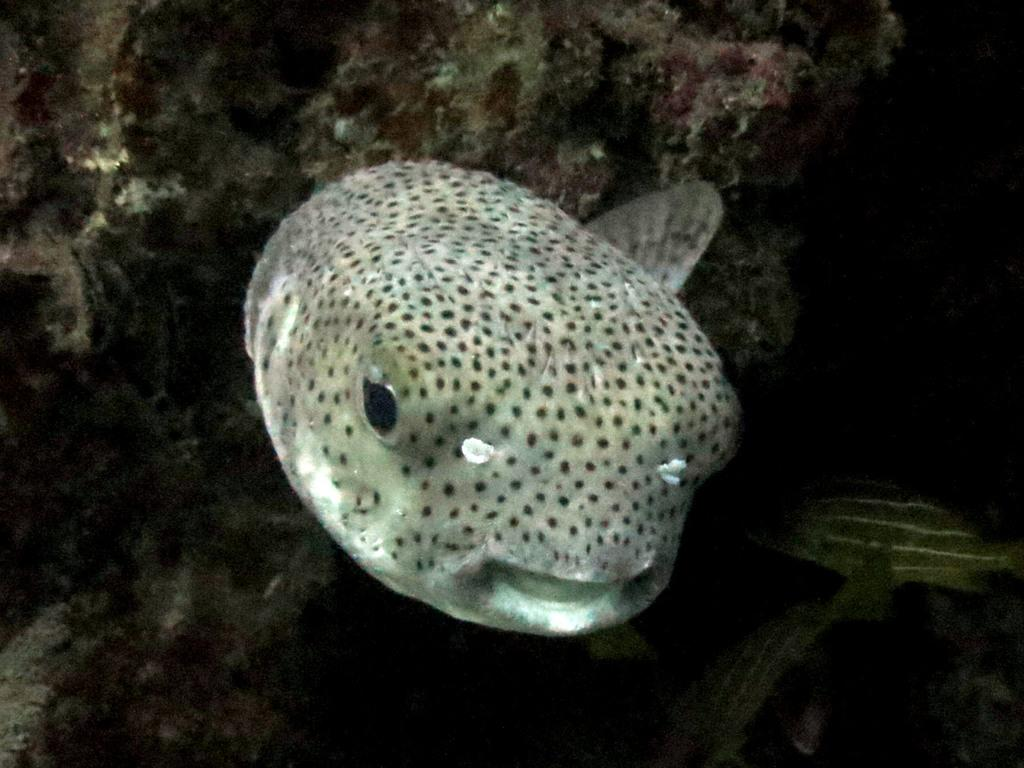What type of living organisms can be seen in the image? The image contains sea animals. What can be seen in the background of the image? There are rocks in the background of the image. How many bears can be seen in the image? There are no bears present in the image; it features sea animals and rocks. What type of nerve is visible in the image? There is no nerve present in the image; it contains sea animals and rocks. 